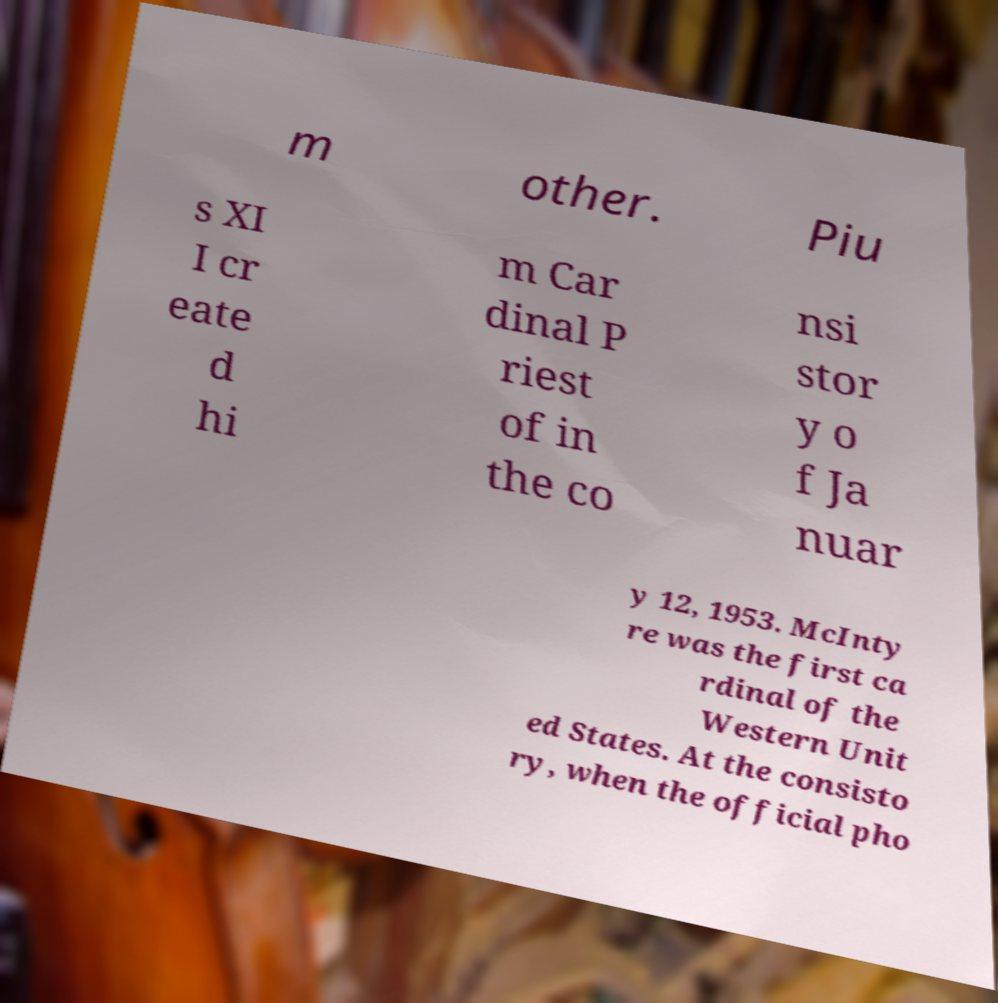What messages or text are displayed in this image? I need them in a readable, typed format. m other. Piu s XI I cr eate d hi m Car dinal P riest of in the co nsi stor y o f Ja nuar y 12, 1953. McInty re was the first ca rdinal of the Western Unit ed States. At the consisto ry, when the official pho 